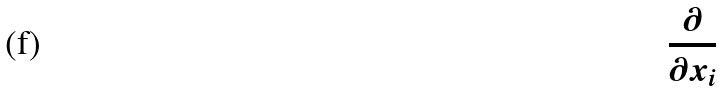<formula> <loc_0><loc_0><loc_500><loc_500>\frac { \partial } { \partial x _ { i } }</formula> 